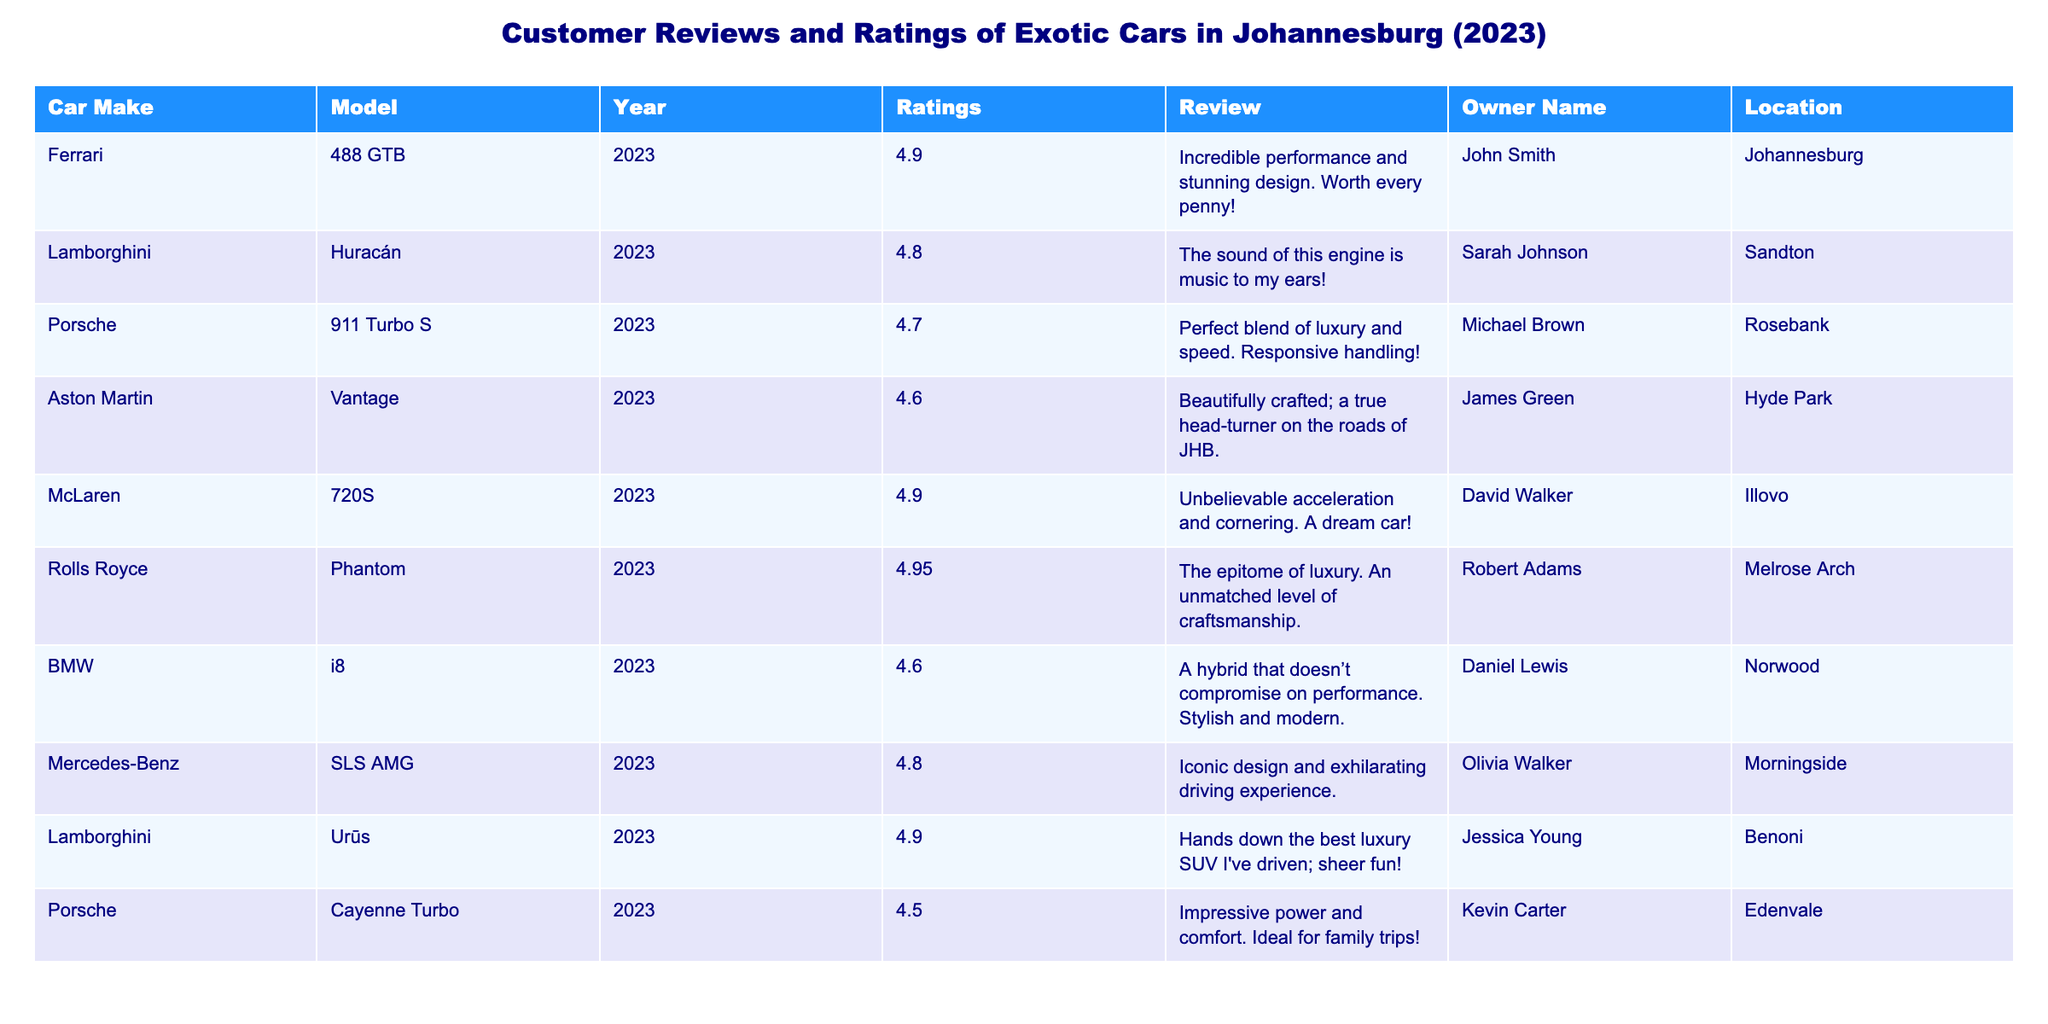What is the highest rating given to a car in the table? The highest rating can be found by checking the 'Ratings' column. The maximum value listed is 4.95, attributed to the Rolls Royce Phantom.
Answer: 4.95 Which car model has the lowest rating? By reviewing the 'Ratings' column, we can identify the car model with the minimum value; the Porsche Cayenne Turbo has the lowest rating of 4.5.
Answer: Porsche Cayenne Turbo How many cars have a rating of 4.9 or higher? We need to count the models with ratings of 4.9 or above. The Ferrari 488 GTB, McLaren 720S, Lamborghini Urüs, and Rolls Royce Phantom each fit this criterion, totaling four cars.
Answer: 4 Is there a car model from BMW? A quick review of the table confirms the presence of the BMW i8, which is included in the data.
Answer: Yes What is the average rating of all the cars listed? To find the average, we sum all the ratings: 4.9 + 4.8 + 4.7 + 4.6 + 4.9 + 4.95 + 4.6 + 4.8 + 4.9 + 4.5 = 48.65. There are ten cars, so the average rating is 48.65 / 10 = 4.865.
Answer: 4.865 Which car model had the review mentioning a "true head-turner"? By scanning through the 'Review' column, the Aston Martin Vantage is the model described as a "true head-turner on the roads of JHB."
Answer: Aston Martin Vantage What percentage of cars have a rating above 4.7? Count the cars with ratings above 4.7: Ferrari, Lamborghini, McLaren, and Rolls Royce give us four cars. There are ten cars total, so the percentage is (4/10) * 100 = 40%.
Answer: 40% Which location has the most exotic cars listed? By evaluating the 'Location' column, we see that there is one car listed from each of the provided locations, indicating no single location has more than one car.
Answer: None Who is the owner of the Lamborghini Urüs? We can simply look at the 'Owner Name' corresponding to the Lamborghini Urüs in the table; it is owned by Jessica Young.
Answer: Jessica Young What is the difference between the highest and lowest rated cars? The highest rating is 4.95 (Rolls Royce Phantom) and the lowest rating is 4.5 (Porsche Cayenne Turbo). The difference is 4.95 - 4.5 = 0.45.
Answer: 0.45 